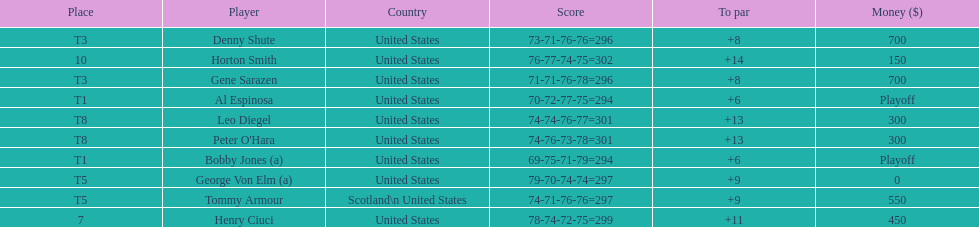Can you parse all the data within this table? {'header': ['Place', 'Player', 'Country', 'Score', 'To par', 'Money ($)'], 'rows': [['T3', 'Denny Shute', 'United States', '73-71-76-76=296', '+8', '700'], ['10', 'Horton Smith', 'United States', '76-77-74-75=302', '+14', '150'], ['T3', 'Gene Sarazen', 'United States', '71-71-76-78=296', '+8', '700'], ['T1', 'Al Espinosa', 'United States', '70-72-77-75=294', '+6', 'Playoff'], ['T8', 'Leo Diegel', 'United States', '74-74-76-77=301', '+13', '300'], ['T8', "Peter O'Hara", 'United States', '74-76-73-78=301', '+13', '300'], ['T1', 'Bobby Jones (a)', 'United States', '69-75-71-79=294', '+6', 'Playoff'], ['T5', 'George Von Elm (a)', 'United States', '79-70-74-74=297', '+9', '0'], ['T5', 'Tommy Armour', 'Scotland\\n\xa0United States', '74-71-76-76=297', '+9', '550'], ['7', 'Henry Ciuci', 'United States', '78-74-72-75=299', '+11', '450']]} What was al espinosa's total stroke count at the final of the 1929 us open? 294. 